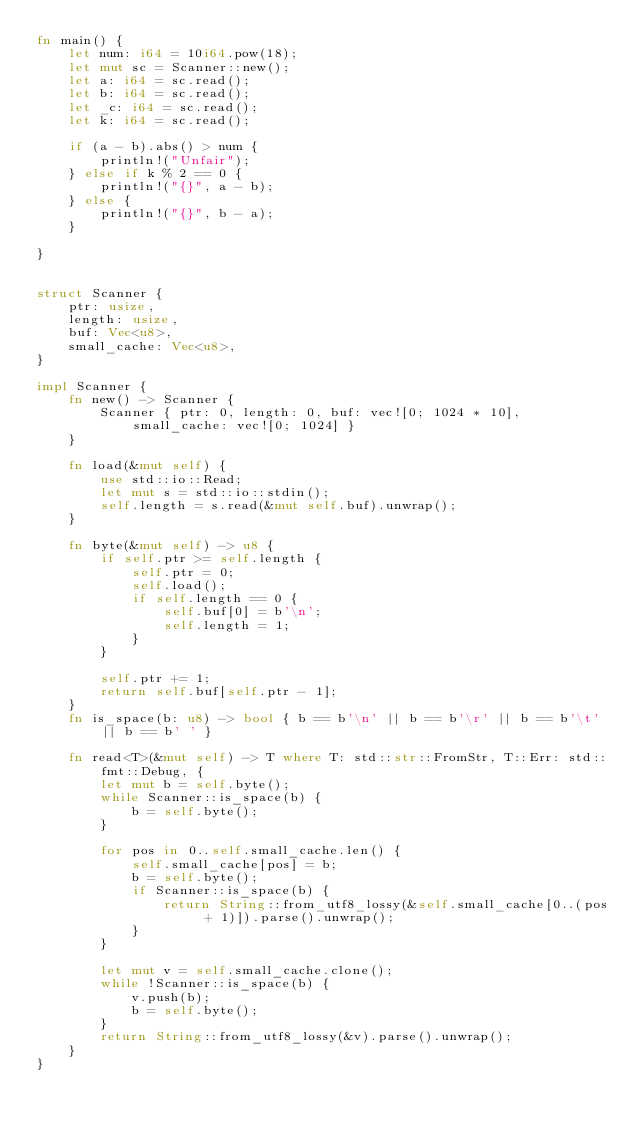Convert code to text. <code><loc_0><loc_0><loc_500><loc_500><_Rust_>fn main() {
    let num: i64 = 10i64.pow(18);
    let mut sc = Scanner::new();
    let a: i64 = sc.read();
    let b: i64 = sc.read();
    let _c: i64 = sc.read();
    let k: i64 = sc.read();

    if (a - b).abs() > num {
        println!("Unfair");
    } else if k % 2 == 0 {
        println!("{}", a - b);
    } else {
        println!("{}", b - a);
    }

}


struct Scanner {
    ptr: usize,
    length: usize,
    buf: Vec<u8>,
    small_cache: Vec<u8>,
}

impl Scanner {
    fn new() -> Scanner {
        Scanner { ptr: 0, length: 0, buf: vec![0; 1024 * 10], small_cache: vec![0; 1024] }
    }

    fn load(&mut self) {
        use std::io::Read;
        let mut s = std::io::stdin();
        self.length = s.read(&mut self.buf).unwrap();
    }

    fn byte(&mut self) -> u8 {
        if self.ptr >= self.length {
            self.ptr = 0;
            self.load();
            if self.length == 0 {
                self.buf[0] = b'\n';
                self.length = 1;
            }
        }

        self.ptr += 1;
        return self.buf[self.ptr - 1];
    }
    fn is_space(b: u8) -> bool { b == b'\n' || b == b'\r' || b == b'\t' || b == b' ' }

    fn read<T>(&mut self) -> T where T: std::str::FromStr, T::Err: std::fmt::Debug, {
        let mut b = self.byte();
        while Scanner::is_space(b) {
            b = self.byte();
        }

        for pos in 0..self.small_cache.len() {
            self.small_cache[pos] = b;
            b = self.byte();
            if Scanner::is_space(b) {
                return String::from_utf8_lossy(&self.small_cache[0..(pos + 1)]).parse().unwrap();
            }
        }

        let mut v = self.small_cache.clone();
        while !Scanner::is_space(b) {
            v.push(b);
            b = self.byte();
        }
        return String::from_utf8_lossy(&v).parse().unwrap();
    }
}</code> 